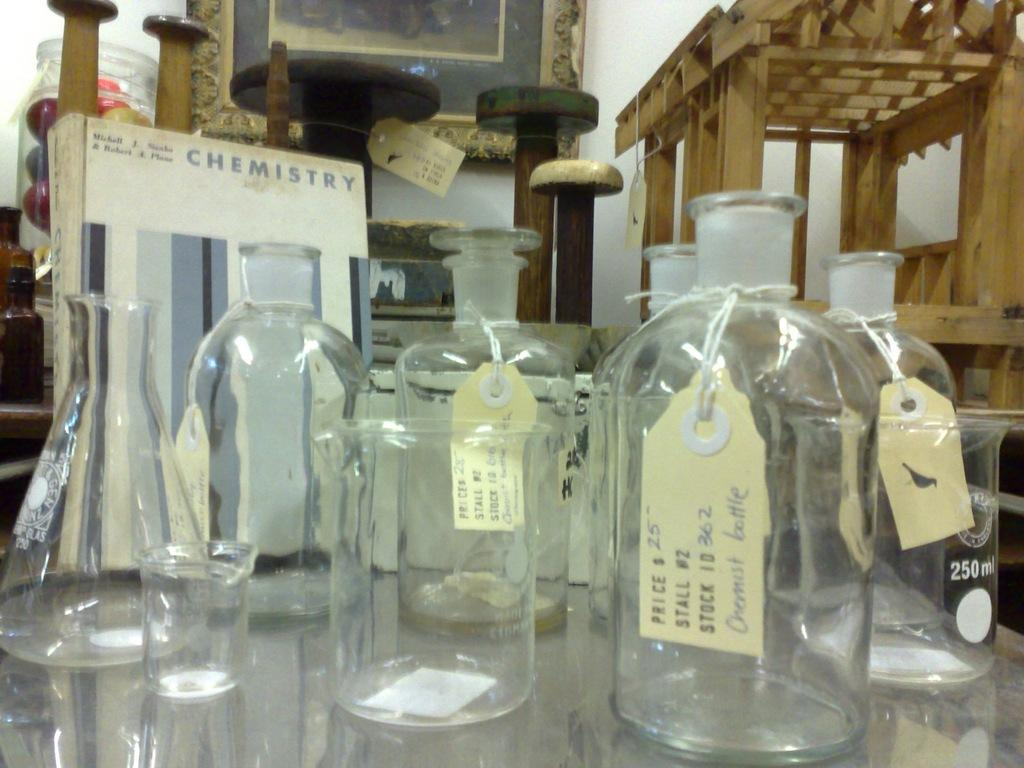<image>
Describe the image concisely. A bunch of glass bottles with tags sits in front of a box that says Chemistry on it. 